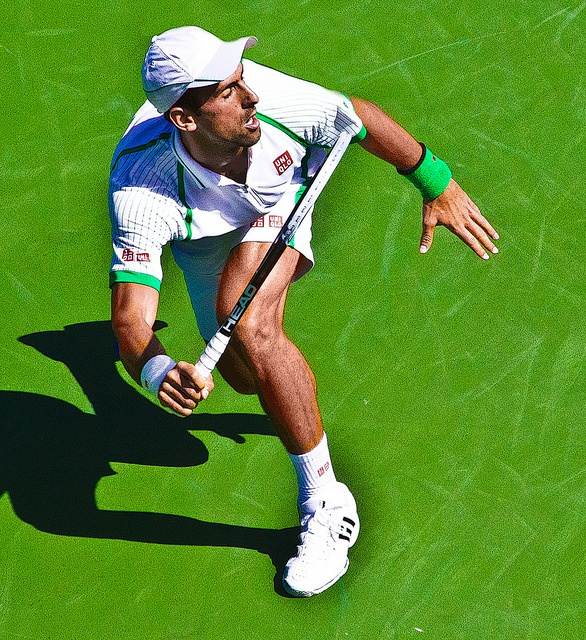Describe the objects in this image and their specific colors. I can see people in green, white, black, maroon, and salmon tones and tennis racket in green, white, black, darkgray, and teal tones in this image. 